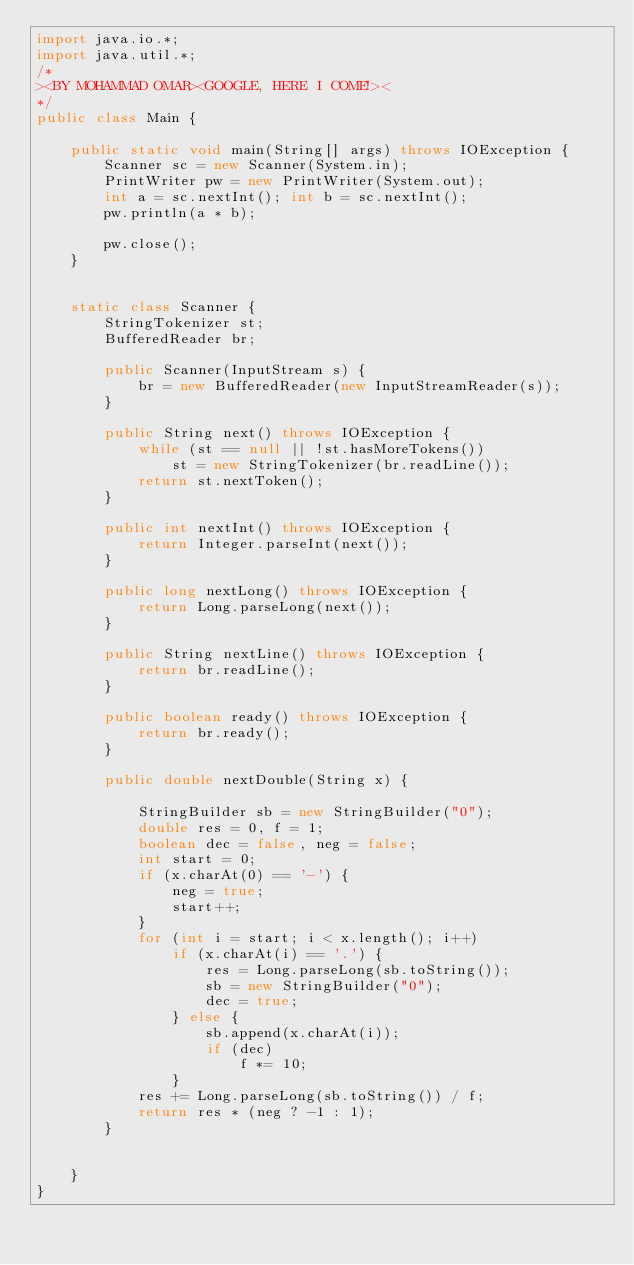Convert code to text. <code><loc_0><loc_0><loc_500><loc_500><_Java_>import java.io.*;
import java.util.*;
/*
><BY MOHAMMAD OMAR><GOOGLE, HERE I COME!><
*/
public class Main {

    public static void main(String[] args) throws IOException {
        Scanner sc = new Scanner(System.in);
        PrintWriter pw = new PrintWriter(System.out);
        int a = sc.nextInt(); int b = sc.nextInt();
        pw.println(a * b);

        pw.close();
    }

    
    static class Scanner {
        StringTokenizer st;
        BufferedReader br;

        public Scanner(InputStream s) {
            br = new BufferedReader(new InputStreamReader(s));
        }

        public String next() throws IOException {
            while (st == null || !st.hasMoreTokens())
                st = new StringTokenizer(br.readLine());
            return st.nextToken();
        }

        public int nextInt() throws IOException {
            return Integer.parseInt(next());
        }

        public long nextLong() throws IOException {
            return Long.parseLong(next());
        }

        public String nextLine() throws IOException {
            return br.readLine();
        }

        public boolean ready() throws IOException {
            return br.ready();
        }

        public double nextDouble(String x) {

            StringBuilder sb = new StringBuilder("0");
            double res = 0, f = 1;
            boolean dec = false, neg = false;
            int start = 0;
            if (x.charAt(0) == '-') {
                neg = true;
                start++;
            }
            for (int i = start; i < x.length(); i++)
                if (x.charAt(i) == '.') {
                    res = Long.parseLong(sb.toString());
                    sb = new StringBuilder("0");
                    dec = true;
                } else {
                    sb.append(x.charAt(i));
                    if (dec)
                        f *= 10;
                }
            res += Long.parseLong(sb.toString()) / f;
            return res * (neg ? -1 : 1);
        }


    }
}
</code> 